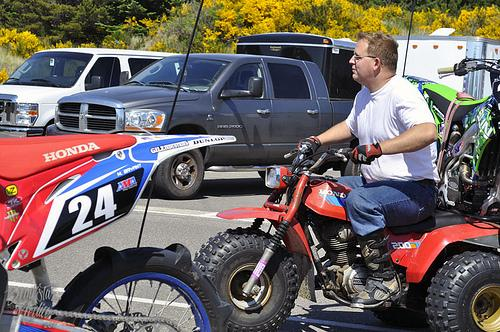Mention a color detail of the tires in the image. There is a blue rim on a tire. Describe the attire of the man riding the vehicle. The man is wearing a white tee shirt, blue jeans, black and orange gloves, and eyeglasses. What kind of vehicle is behind the man in the image? There is a green bike in the background behind the man. Identify the color and type of vehicle the man is riding. The man is riding a red motor vehicle. What is the color and type of a vehicle in the background? There is a gray pickup truck in the background. Briefly describe the scene presented in the image. A man is riding a red motor vehicle, with a green bike in the background, and various vehicles like a gray pickup truck and a white van, while wearing a white t-shirt, blue jeans, gloves, and eyeglasses. What numbers can be seen on the red motor vehicle? The number 24 is in white lettering. 